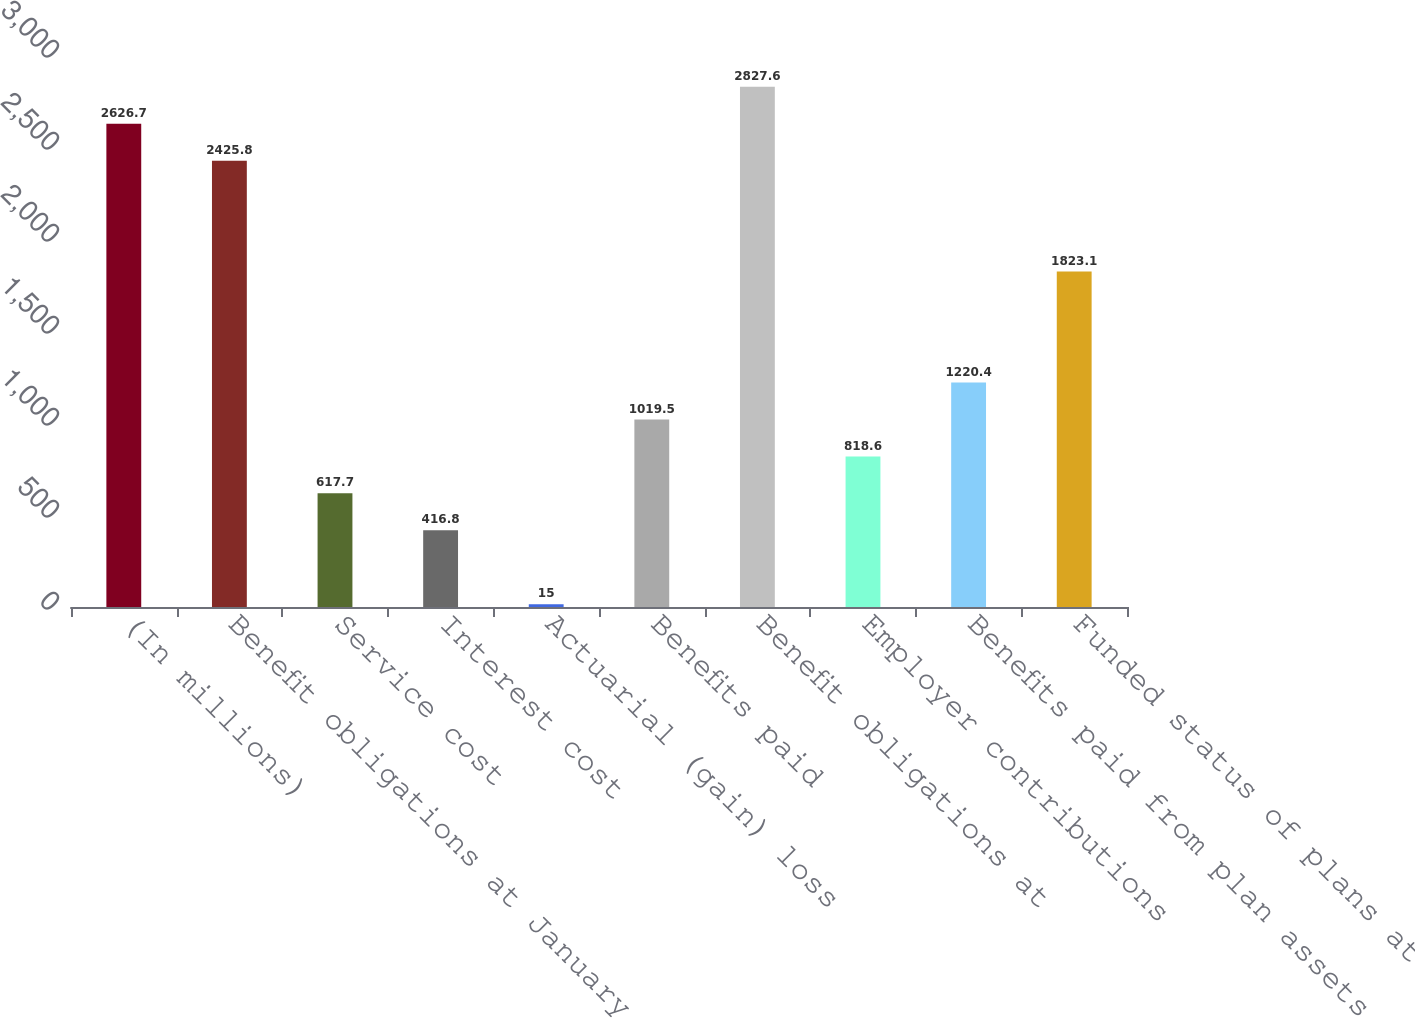Convert chart. <chart><loc_0><loc_0><loc_500><loc_500><bar_chart><fcel>(In millions)<fcel>Benefit obligations at January<fcel>Service cost<fcel>Interest cost<fcel>Actuarial (gain) loss<fcel>Benefits paid<fcel>Benefit obligations at<fcel>Employer contributions<fcel>Benefits paid from plan assets<fcel>Funded status of plans at<nl><fcel>2626.7<fcel>2425.8<fcel>617.7<fcel>416.8<fcel>15<fcel>1019.5<fcel>2827.6<fcel>818.6<fcel>1220.4<fcel>1823.1<nl></chart> 